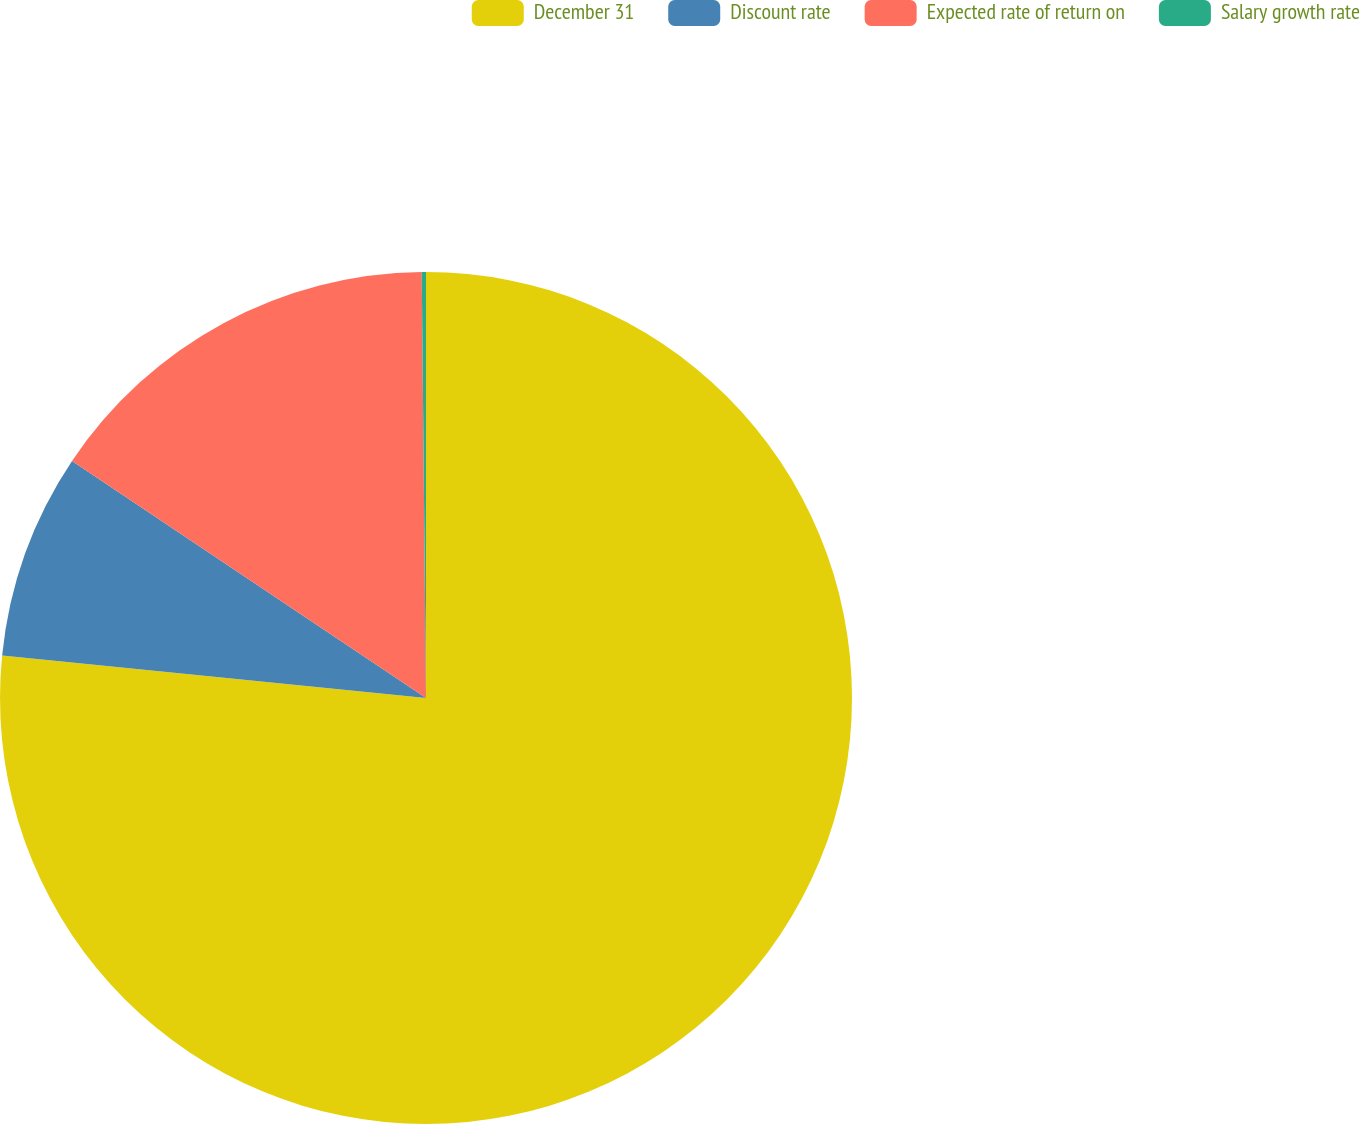Convert chart. <chart><loc_0><loc_0><loc_500><loc_500><pie_chart><fcel>December 31<fcel>Discount rate<fcel>Expected rate of return on<fcel>Salary growth rate<nl><fcel>76.59%<fcel>7.8%<fcel>15.45%<fcel>0.16%<nl></chart> 